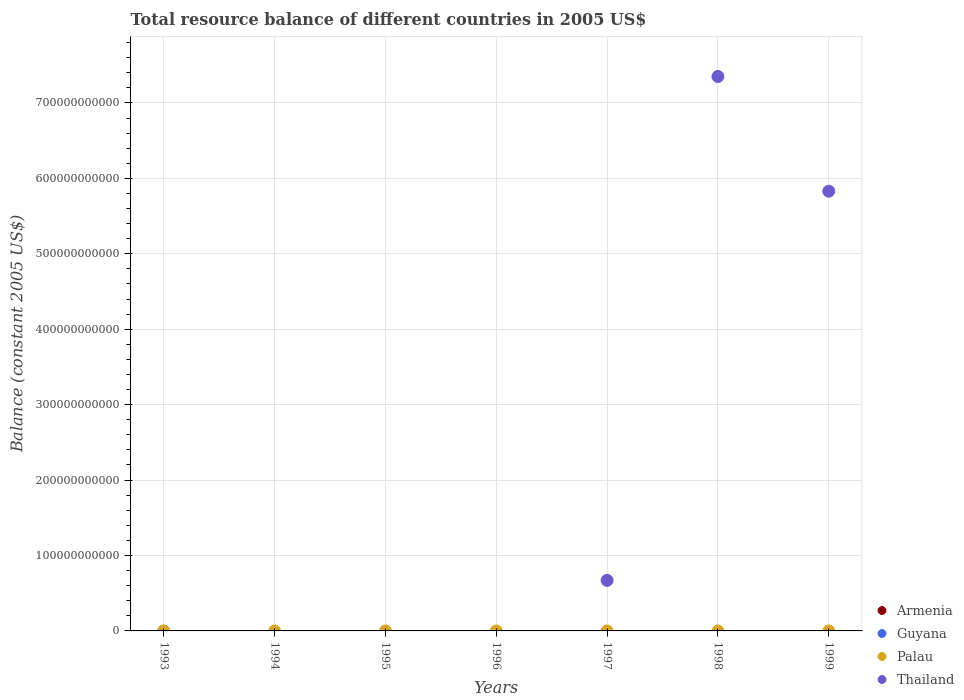How many different coloured dotlines are there?
Provide a succinct answer. 1. Is the number of dotlines equal to the number of legend labels?
Make the answer very short. No. Across all years, what is the maximum total resource balance in Thailand?
Offer a terse response. 7.35e+11. What is the total total resource balance in Armenia in the graph?
Offer a terse response. 0. What is the difference between the total resource balance in Palau in 1994 and the total resource balance in Guyana in 1995?
Keep it short and to the point. 0. What is the difference between the highest and the second highest total resource balance in Thailand?
Your response must be concise. 1.52e+11. What is the difference between the highest and the lowest total resource balance in Thailand?
Provide a short and direct response. 7.35e+11. Is it the case that in every year, the sum of the total resource balance in Thailand and total resource balance in Armenia  is greater than the sum of total resource balance in Palau and total resource balance in Guyana?
Offer a very short reply. No. Does the total resource balance in Armenia monotonically increase over the years?
Your response must be concise. No. Is the total resource balance in Thailand strictly less than the total resource balance in Guyana over the years?
Offer a very short reply. No. What is the difference between two consecutive major ticks on the Y-axis?
Offer a very short reply. 1.00e+11. Does the graph contain any zero values?
Your response must be concise. Yes. Does the graph contain grids?
Provide a short and direct response. Yes. How many legend labels are there?
Offer a very short reply. 4. How are the legend labels stacked?
Your answer should be very brief. Vertical. What is the title of the graph?
Your answer should be compact. Total resource balance of different countries in 2005 US$. Does "Moldova" appear as one of the legend labels in the graph?
Give a very brief answer. No. What is the label or title of the Y-axis?
Offer a terse response. Balance (constant 2005 US$). What is the Balance (constant 2005 US$) in Guyana in 1993?
Make the answer very short. 0. What is the Balance (constant 2005 US$) in Armenia in 1994?
Give a very brief answer. 0. What is the Balance (constant 2005 US$) of Palau in 1994?
Provide a short and direct response. 0. What is the Balance (constant 2005 US$) in Guyana in 1995?
Your response must be concise. 0. What is the Balance (constant 2005 US$) of Armenia in 1996?
Keep it short and to the point. 0. What is the Balance (constant 2005 US$) of Guyana in 1996?
Keep it short and to the point. 0. What is the Balance (constant 2005 US$) in Armenia in 1997?
Provide a short and direct response. 0. What is the Balance (constant 2005 US$) in Palau in 1997?
Your answer should be very brief. 0. What is the Balance (constant 2005 US$) of Thailand in 1997?
Offer a very short reply. 6.70e+1. What is the Balance (constant 2005 US$) of Guyana in 1998?
Ensure brevity in your answer.  0. What is the Balance (constant 2005 US$) in Thailand in 1998?
Provide a succinct answer. 7.35e+11. What is the Balance (constant 2005 US$) of Palau in 1999?
Offer a very short reply. 0. What is the Balance (constant 2005 US$) in Thailand in 1999?
Your answer should be compact. 5.83e+11. Across all years, what is the maximum Balance (constant 2005 US$) of Thailand?
Keep it short and to the point. 7.35e+11. Across all years, what is the minimum Balance (constant 2005 US$) of Thailand?
Offer a very short reply. 0. What is the total Balance (constant 2005 US$) of Palau in the graph?
Keep it short and to the point. 0. What is the total Balance (constant 2005 US$) in Thailand in the graph?
Give a very brief answer. 1.39e+12. What is the difference between the Balance (constant 2005 US$) of Thailand in 1997 and that in 1998?
Give a very brief answer. -6.68e+11. What is the difference between the Balance (constant 2005 US$) of Thailand in 1997 and that in 1999?
Your answer should be very brief. -5.16e+11. What is the difference between the Balance (constant 2005 US$) of Thailand in 1998 and that in 1999?
Ensure brevity in your answer.  1.52e+11. What is the average Balance (constant 2005 US$) in Armenia per year?
Ensure brevity in your answer.  0. What is the average Balance (constant 2005 US$) in Thailand per year?
Your answer should be very brief. 1.98e+11. What is the ratio of the Balance (constant 2005 US$) in Thailand in 1997 to that in 1998?
Provide a short and direct response. 0.09. What is the ratio of the Balance (constant 2005 US$) in Thailand in 1997 to that in 1999?
Keep it short and to the point. 0.11. What is the ratio of the Balance (constant 2005 US$) of Thailand in 1998 to that in 1999?
Make the answer very short. 1.26. What is the difference between the highest and the second highest Balance (constant 2005 US$) in Thailand?
Offer a terse response. 1.52e+11. What is the difference between the highest and the lowest Balance (constant 2005 US$) of Thailand?
Offer a very short reply. 7.35e+11. 